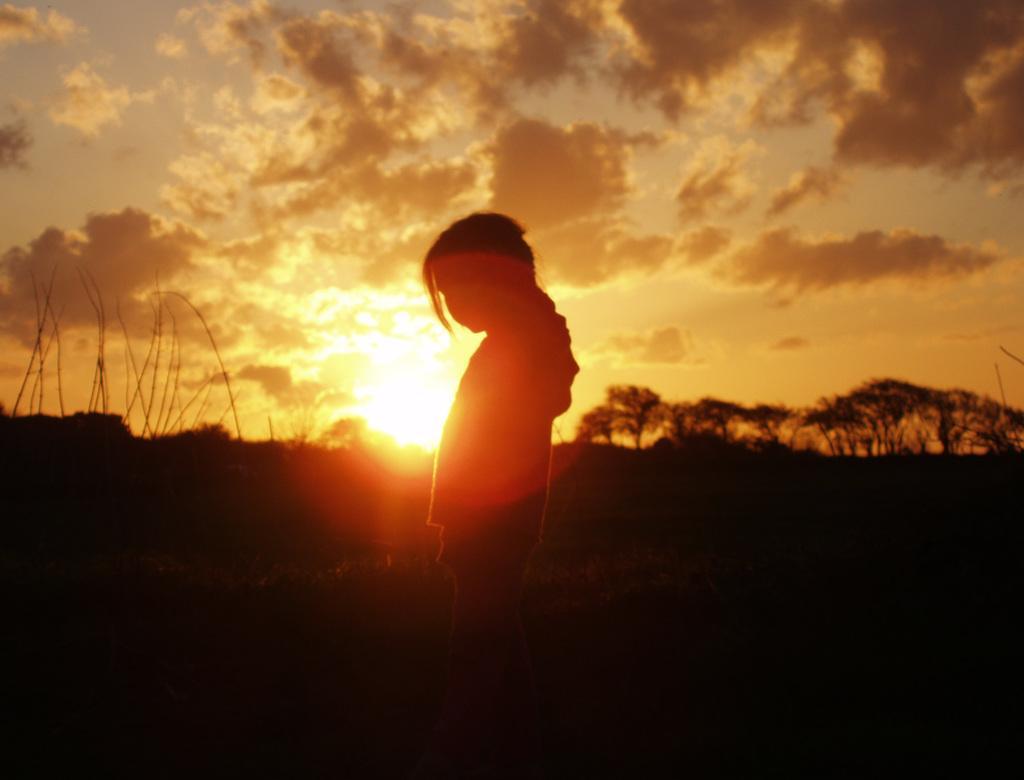In one or two sentences, can you explain what this image depicts? This is an outside view. In the middle of the image there is a person standing facing towards the left side. In the background there are trees. At the top of the image I can see the sky along with the clouds and sun. 